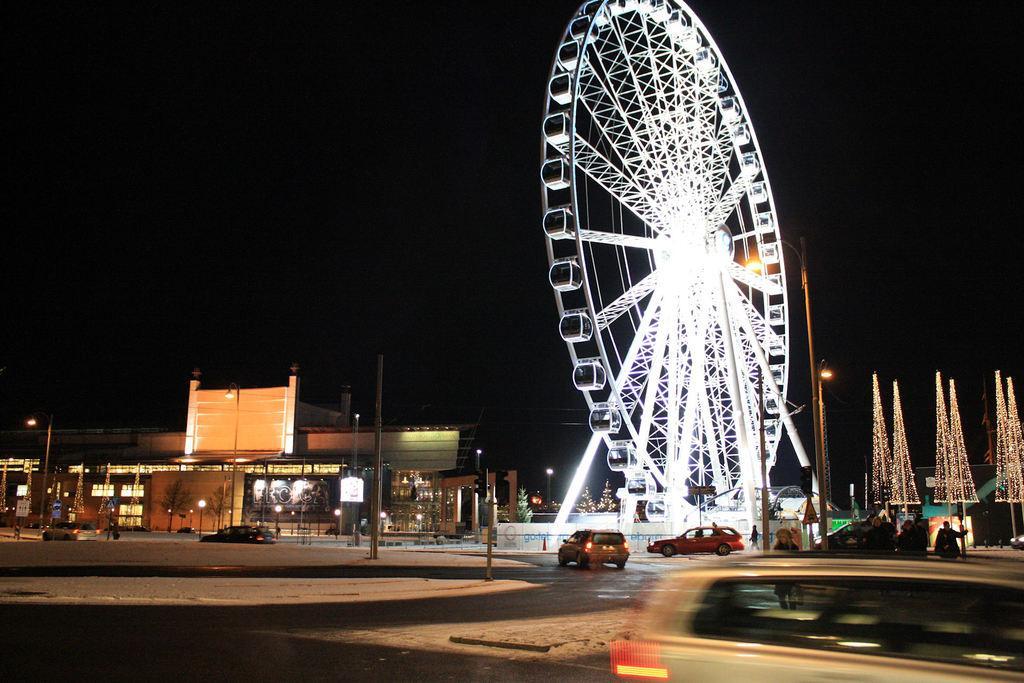Describe this image in one or two sentences. In this image few vehicles are on the road. There are poles on the pavement. Right side there are decorative lights. Middle of the image there is a giant wheel. Left side there are buildings. Before it there are street lights. Top of the image there is sky. Few people are on the pavement. 